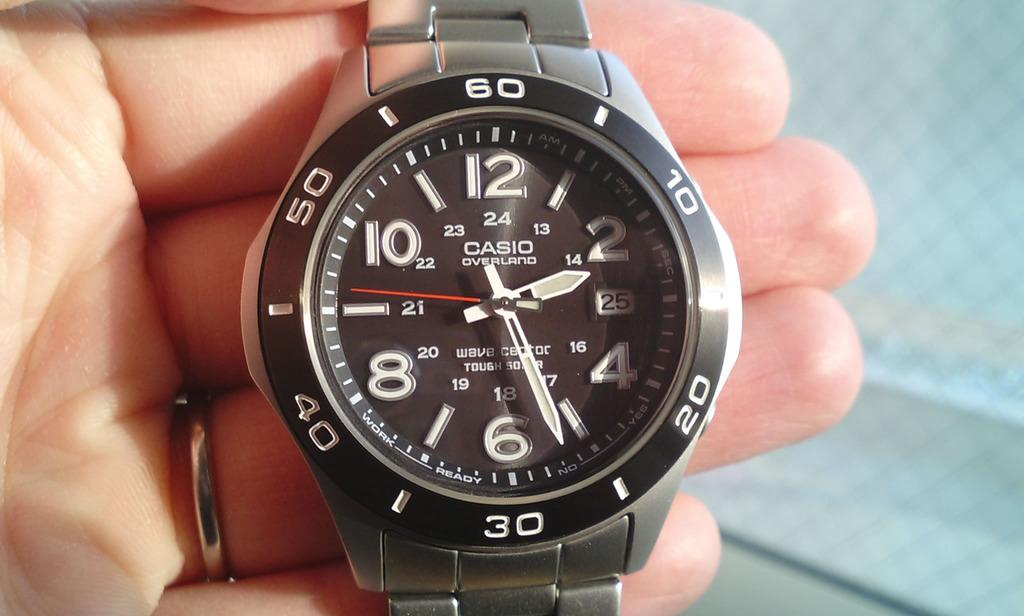Provide a one-sentence caption for the provided image. A casio overland watch face with large numbers is held in a hand. 